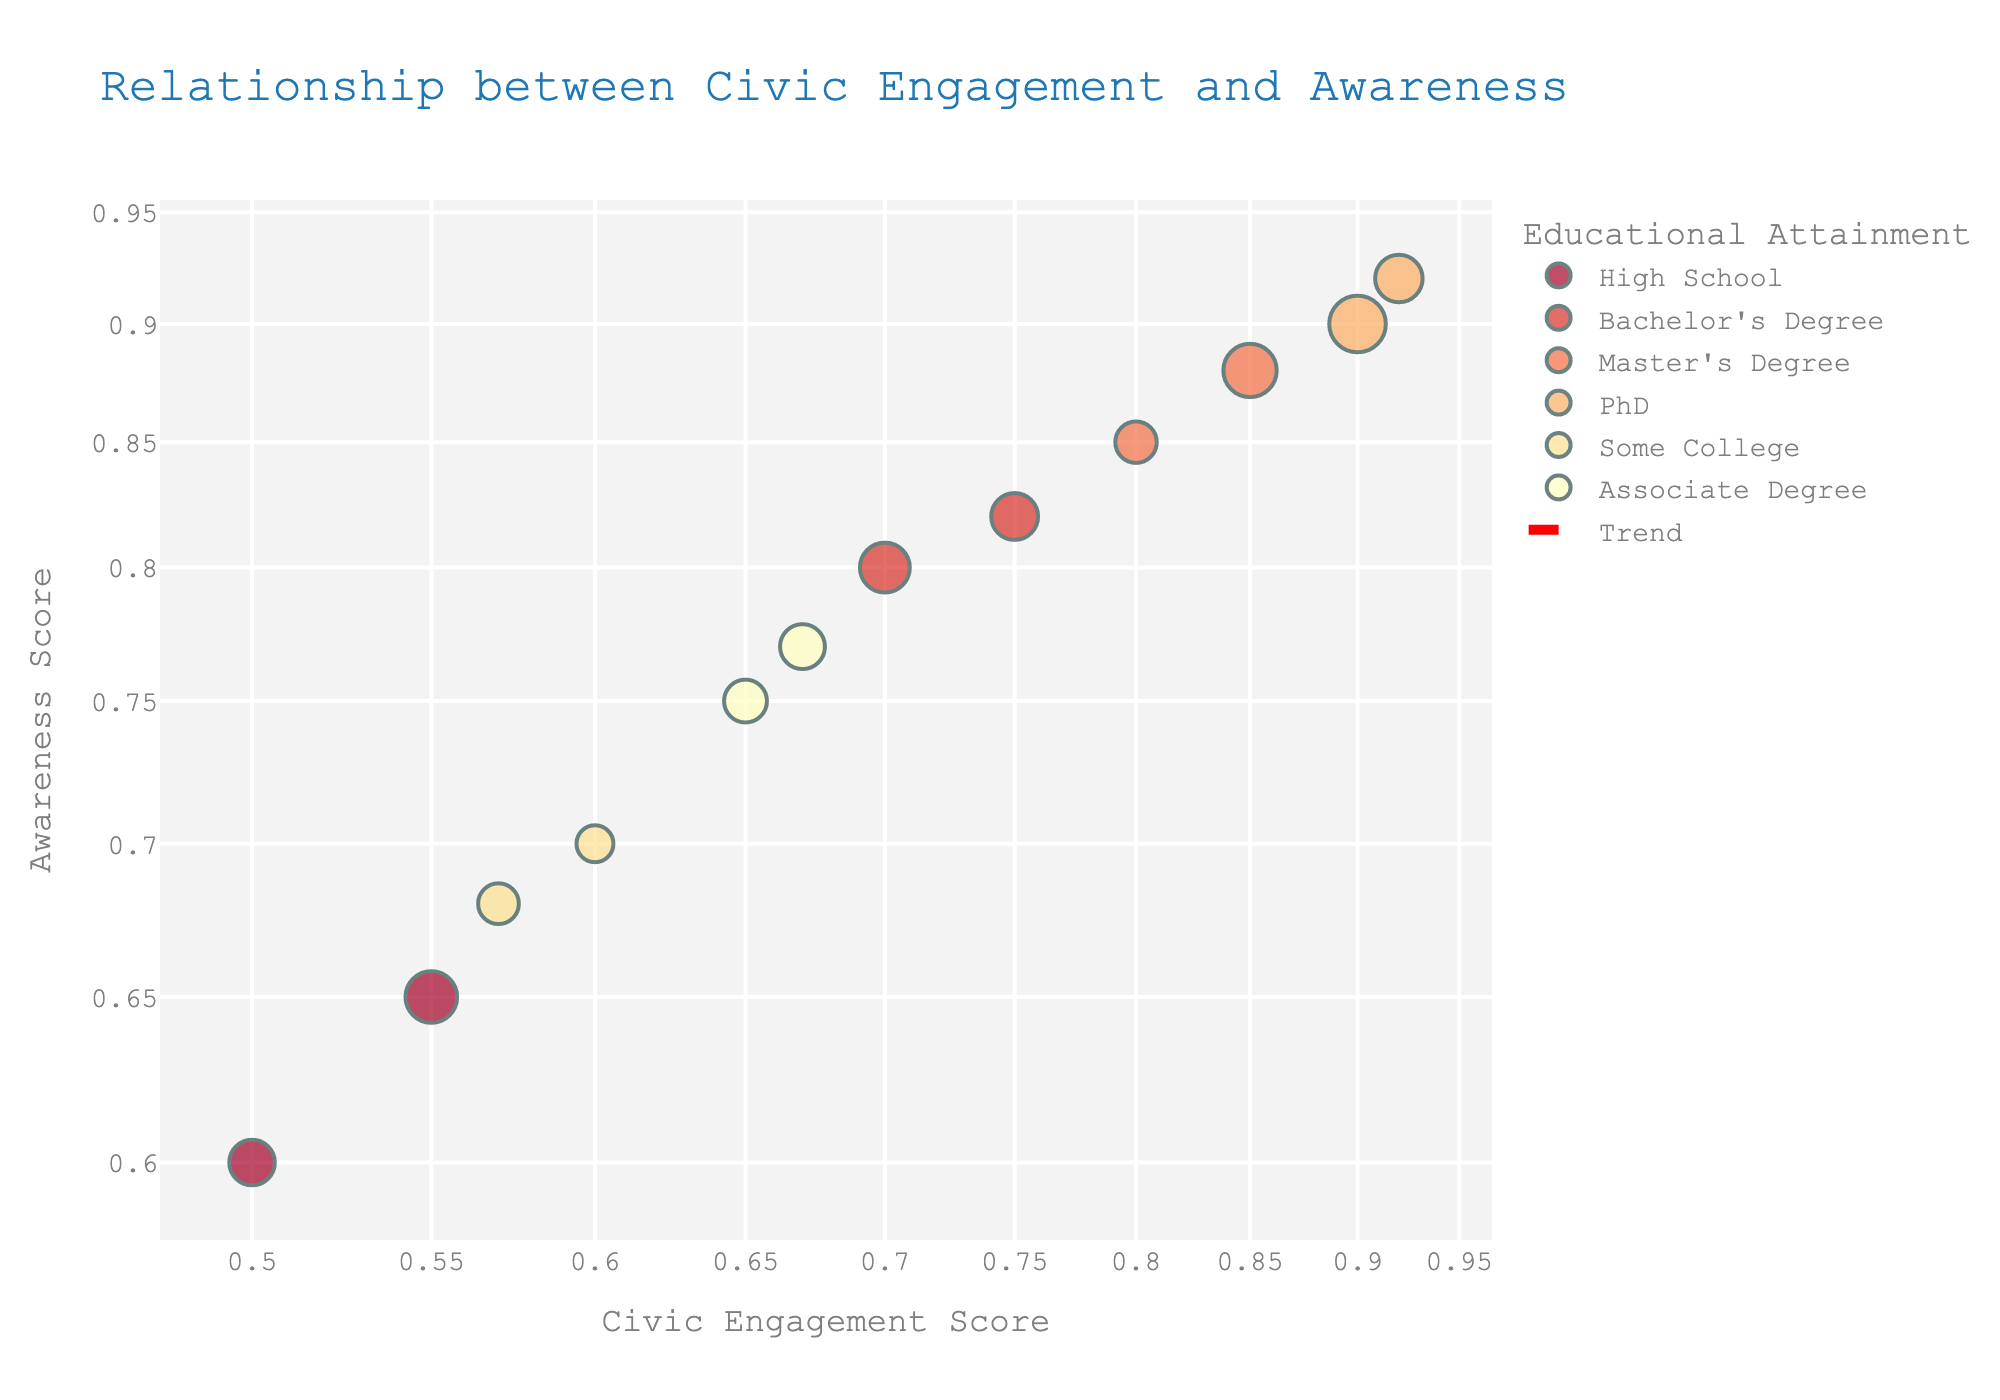What is the title of the figure? The title is typically displayed at the top of the figure. In this plot, you can observe the title in a larger font size and a distinct color.
Answer: Relationship between Civic Engagement and Awareness How many data points are represented in the figure? Each data point corresponds to an individual in the dataset. By counting the number of marks on the plot, you can determine the total number of data points.
Answer: 12 Which educational attainment level has the highest awareness score? Identify the data point that has the highest vertical position (awareness score) and check its color or hover annotation indicating the educational attainment level.
Answer: PhD What is the range of ages represented in the plot? The size of each data point represents the age. By observing the smallest and largest data point sizes, you can identify the age range.
Answer: 23 to 54 Which gender has the highest civic engagement score? Find the data point with the highest horizontal position (civic engagement score) and check its hover annotation for the gender information.
Answer: Female What is the relationship between educational attainment and civic engagement? Observe the general trend of data points as educational attainment levels change. Evaluate if higher educational levels are associated with higher or lower civic engagement scores.
Answer: Higher educational attainment is associated with higher civic engagement How many educational levels have at least one person with a civic engagement score above 0.7? Identify the data points with civic engagement scores greater than 0.7, and count the distinct educational levels they represent.
Answer: 4 What is the median value of awareness for data points with a Master’s degree? List out the awareness scores for all data points with a Master’s degree, sort them in ascending order, and find the middle value. If there's an even number of observations, average the two middle values.
Answer: 0.865 Which ethnicity shows the most variation in civic engagement scores? Compare the range of civic engagement scores (difference between the highest and lowest scores) for data points within each ethnicity group.
Answer: Hispanic How is gender diversity represented among high school graduates in terms of civic engagement and awareness? Identify the data points for high school graduates, look at the gender in the hover annotations, and compare their civic engagement and awareness scores.
Answer: There are high school graduates represented by males and females, showing varying scores but generally lower compared to higher educational levels 